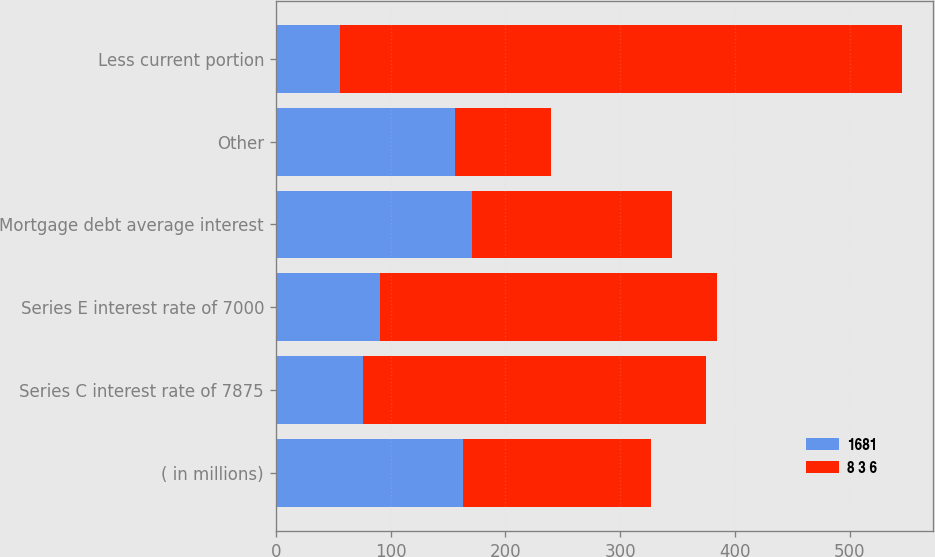Convert chart to OTSL. <chart><loc_0><loc_0><loc_500><loc_500><stacked_bar_chart><ecel><fcel>( in millions)<fcel>Series C interest rate of 7875<fcel>Series E interest rate of 7000<fcel>Mortgage debt average interest<fcel>Other<fcel>Less current portion<nl><fcel>1681<fcel>163.5<fcel>76<fcel>91<fcel>171<fcel>156<fcel>56<nl><fcel>8 3 6<fcel>163.5<fcel>299<fcel>293<fcel>174<fcel>84<fcel>489<nl></chart> 